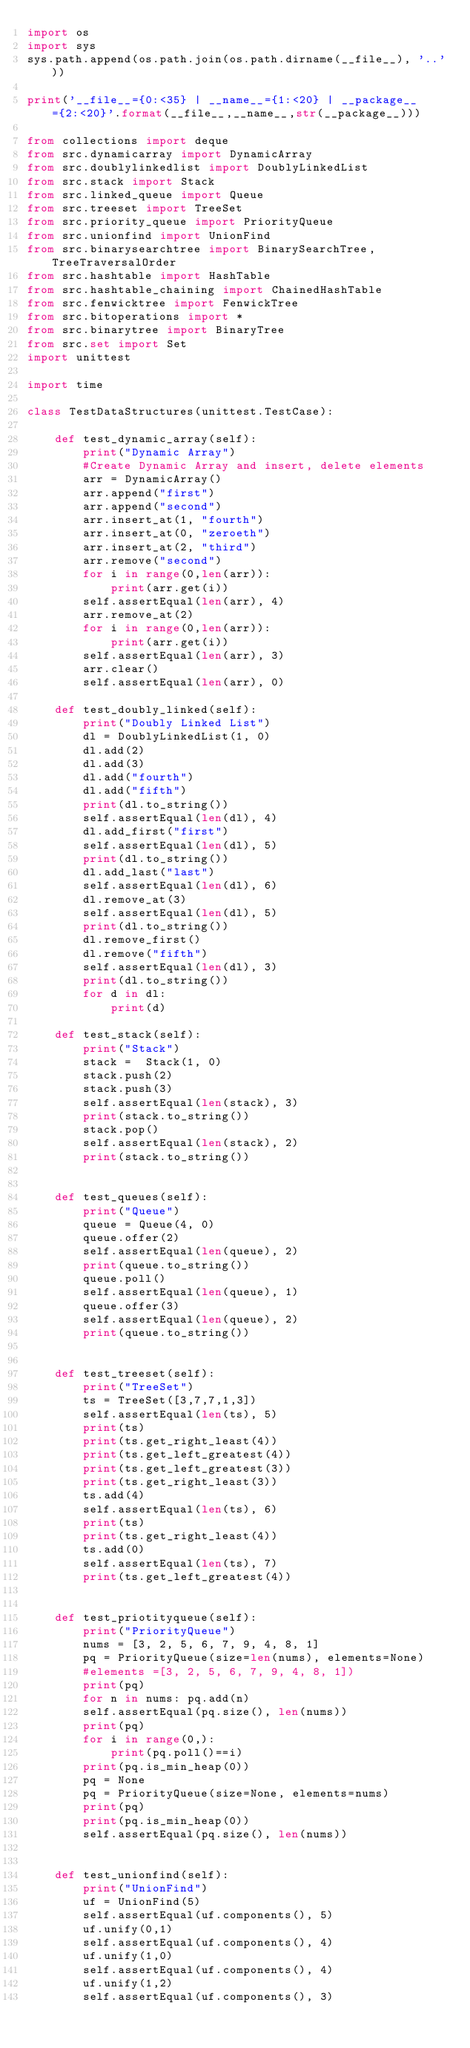<code> <loc_0><loc_0><loc_500><loc_500><_Python_>import os
import sys
sys.path.append(os.path.join(os.path.dirname(__file__), '..'))

print('__file__={0:<35} | __name__={1:<20} | __package__={2:<20}'.format(__file__,__name__,str(__package__)))

from collections import deque
from src.dynamicarray import DynamicArray 
from src.doublylinkedlist import DoublyLinkedList
from src.stack import Stack
from src.linked_queue import Queue
from src.treeset import TreeSet
from src.priority_queue import PriorityQueue
from src.unionfind import UnionFind
from src.binarysearchtree import BinarySearchTree, TreeTraversalOrder
from src.hashtable import HashTable
from src.hashtable_chaining import ChainedHashTable
from src.fenwicktree import FenwickTree
from src.bitoperations import *
from src.binarytree import BinaryTree
from src.set import Set
import unittest

import time

class TestDataStructures(unittest.TestCase):

    def test_dynamic_array(self):
        print("Dynamic Array")
        #Create Dynamic Array and insert, delete elements
        arr = DynamicArray()
        arr.append("first")
        arr.append("second")
        arr.insert_at(1, "fourth")
        arr.insert_at(0, "zeroeth")
        arr.insert_at(2, "third")
        arr.remove("second")
        for i in range(0,len(arr)):
            print(arr.get(i))
        self.assertEqual(len(arr), 4)
        arr.remove_at(2)
        for i in range(0,len(arr)):
            print(arr.get(i))
        self.assertEqual(len(arr), 3)
        arr.clear()
        self.assertEqual(len(arr), 0)

    def test_doubly_linked(self):
        print("Doubly Linked List")
        dl = DoublyLinkedList(1, 0)
        dl.add(2)
        dl.add(3)
        dl.add("fourth")
        dl.add("fifth")
        print(dl.to_string())
        self.assertEqual(len(dl), 4)
        dl.add_first("first")
        self.assertEqual(len(dl), 5)
        print(dl.to_string())
        dl.add_last("last")
        self.assertEqual(len(dl), 6)
        dl.remove_at(3)
        self.assertEqual(len(dl), 5)
        print(dl.to_string())
        dl.remove_first()
        dl.remove("fifth")
        self.assertEqual(len(dl), 3)
        print(dl.to_string())
        for d in dl:
            print(d)

    def test_stack(self):
        print("Stack")
        stack =  Stack(1, 0)
        stack.push(2)
        stack.push(3)
        self.assertEqual(len(stack), 3)
        print(stack.to_string())
        stack.pop()
        self.assertEqual(len(stack), 2)
        print(stack.to_string())


    def test_queues(self):
        print("Queue")
        queue = Queue(4, 0)
        queue.offer(2)
        self.assertEqual(len(queue), 2)
        print(queue.to_string())
        queue.poll()
        self.assertEqual(len(queue), 1)
        queue.offer(3)
        self.assertEqual(len(queue), 2)
        print(queue.to_string())


    def test_treeset(self):
        print("TreeSet")
        ts = TreeSet([3,7,7,1,3])
        self.assertEqual(len(ts), 5)
        print(ts)
        print(ts.get_right_least(4))
        print(ts.get_left_greatest(4))
        print(ts.get_left_greatest(3))
        print(ts.get_right_least(3))
        ts.add(4)
        self.assertEqual(len(ts), 6)
        print(ts)
        print(ts.get_right_least(4))
        ts.add(0)
        self.assertEqual(len(ts), 7)
        print(ts.get_left_greatest(4))


    def test_priotityqueue(self):
        print("PriorityQueue")
        nums = [3, 2, 5, 6, 7, 9, 4, 8, 1]
        pq = PriorityQueue(size=len(nums), elements=None)
        #elements =[3, 2, 5, 6, 7, 9, 4, 8, 1])
        print(pq)
        for n in nums: pq.add(n)
        self.assertEqual(pq.size(), len(nums))
        print(pq)
        for i in range(0,): 
            print(pq.poll()==i)
        print(pq.is_min_heap(0))
        pq = None
        pq = PriorityQueue(size=None, elements=nums)
        print(pq)
        print(pq.is_min_heap(0))
        self.assertEqual(pq.size(), len(nums))


    def test_unionfind(self):
        print("UnionFind")
        uf = UnionFind(5)
        self.assertEqual(uf.components(), 5)
        uf.unify(0,1)
        self.assertEqual(uf.components(), 4)
        uf.unify(1,0)
        self.assertEqual(uf.components(), 4)
        uf.unify(1,2)
        self.assertEqual(uf.components(), 3)</code> 